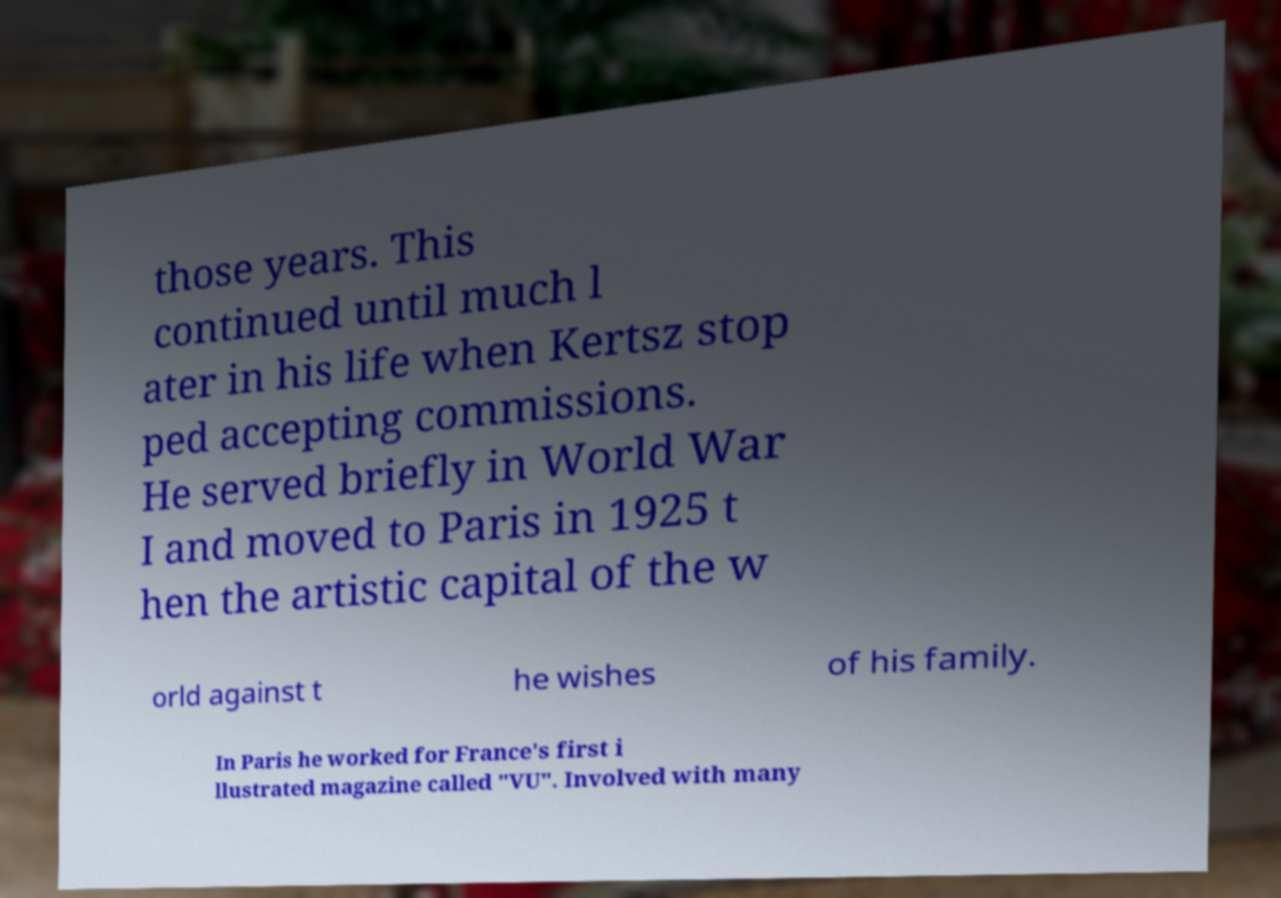Can you accurately transcribe the text from the provided image for me? those years. This continued until much l ater in his life when Kertsz stop ped accepting commissions. He served briefly in World War I and moved to Paris in 1925 t hen the artistic capital of the w orld against t he wishes of his family. In Paris he worked for France's first i llustrated magazine called "VU". Involved with many 